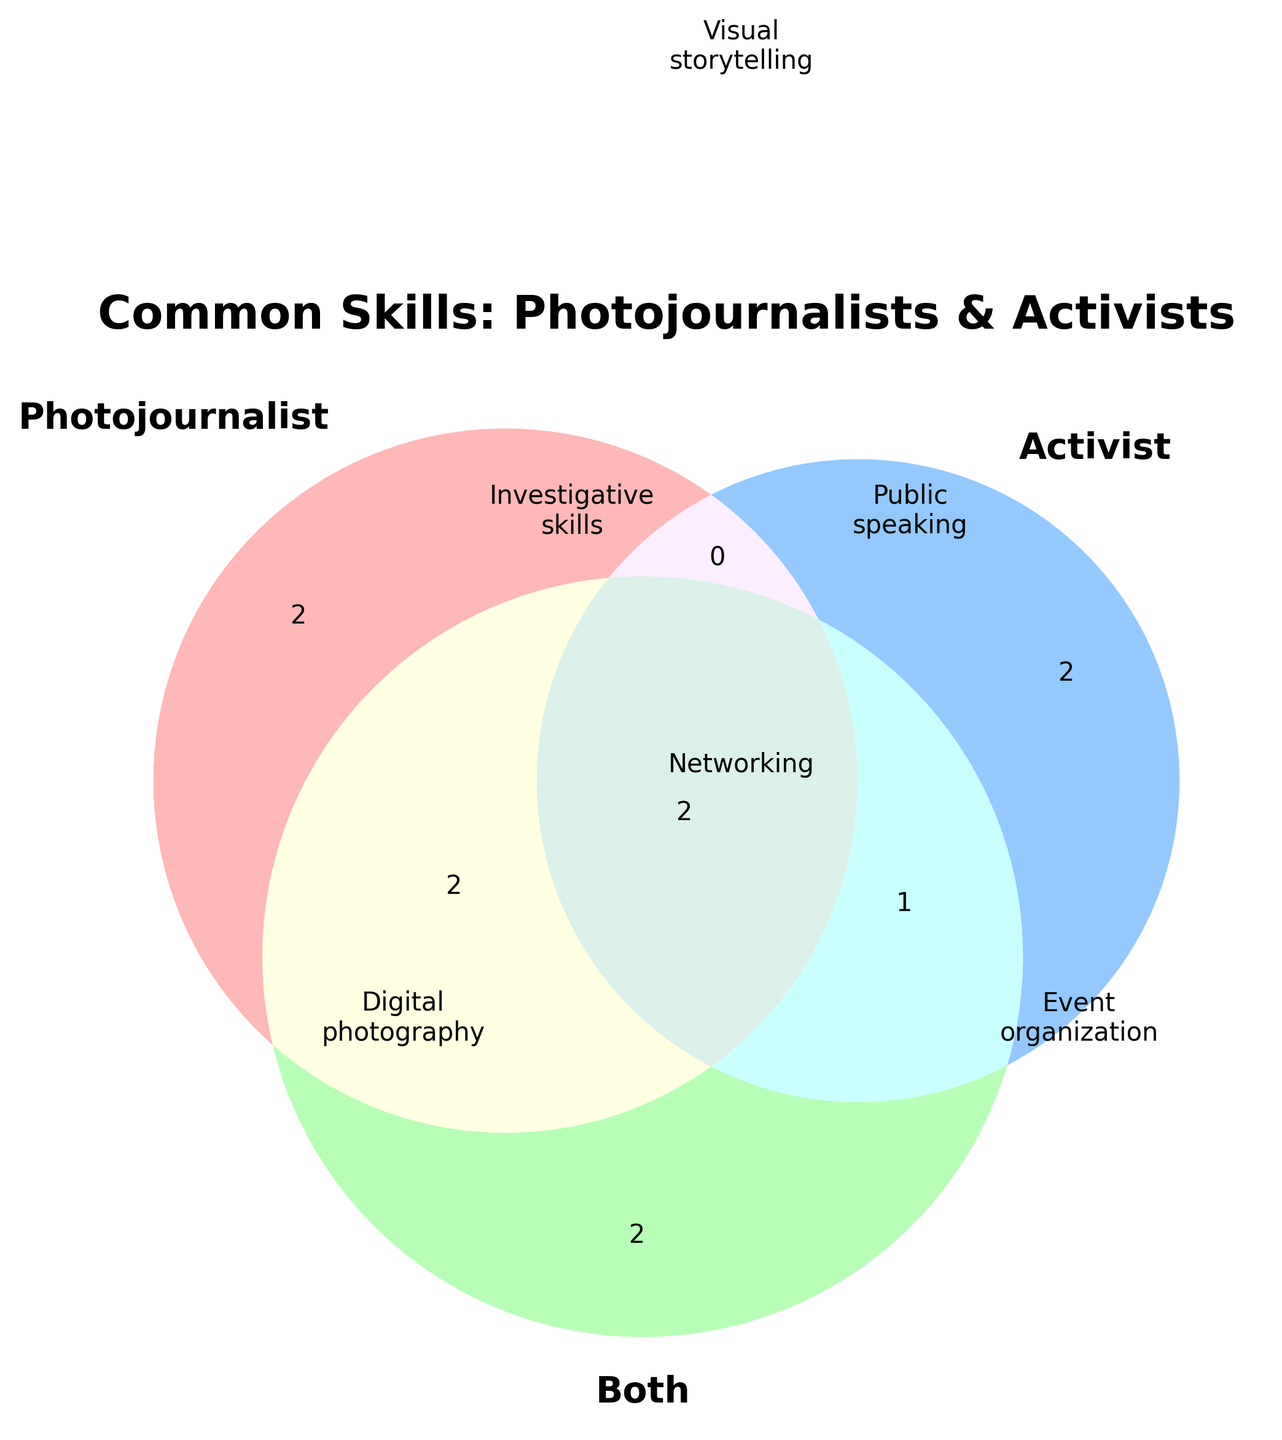How many skills are common to both photojournalists and activists? Examine the intersecting area labeled 'Both' in the Venn diagram. These include social media management, networking, risk assessment, and cultural sensitivity.
Answer: 4 Which specific skills are unique to photojournalists? Look at the section of the Venn diagram that exclusively represents photojournalists. The unique skills are digital photography and editing software proficiency.
Answer: Digital photography, editing software proficiency What skill appears only for activists but not for photojournalists? Find the section of the Venn diagram exclusive to activists. The unique skills for activists are event organization and crowd management.
Answer: Event organization, crowd management How many skills do photojournalists and activists have in common? Count the overlapping region between the areas representing photojournalists and activists. These are public speaking, risk assessment, and cultural sensitivity.
Answer: 3 Are there any skills common between photojournalists, activists, and the both category? Look for the intersecting area that connects photojournalists, activists, and the both category. These skills are included in the region marked 'Both' that overlaps with both other areas.
Answer: Yes What skills are common between photojournalists and the 'Both' category but not activists? Find the section where photojournalists overlap with the 'Both' category but exclude the part where activists are also included. These are visual storytelling and investigative skills.
Answer: Visual storytelling, investigative skills Which skill is common among photojournalists, activists, and both categories alike? Identify the skill inside the intersection of all three Venn diagram circles.
Answer: Risk assessment, cultural sensitivity What's the total number of unique skills listed in the Venn diagram? Count each skill in the Venn diagram, making sure not to double-count any that appear in multiple areas. These are visual storytelling, public speaking, digital photography, social media management, networking, investigative skills, event organization, editing software proficiency, crowd management, risk assessment, cultural sensitivity.
Answer: 11 Do photojournalists or activists have more unique skills? Compare the exclusive sections for photojournalists and activists. Photojournalists have two unique skills (digital photography and editing software proficiency), while activists have two unique skills (event organization and crowd management). Both categories have equal numbers.
Answer: Equal Which skill is both common to activists and the 'Both' category but not photojournalists? Examine the intersection area between activists and the 'Both' category but exclude the intersection with photojournalists.
Answer: Public speaking 